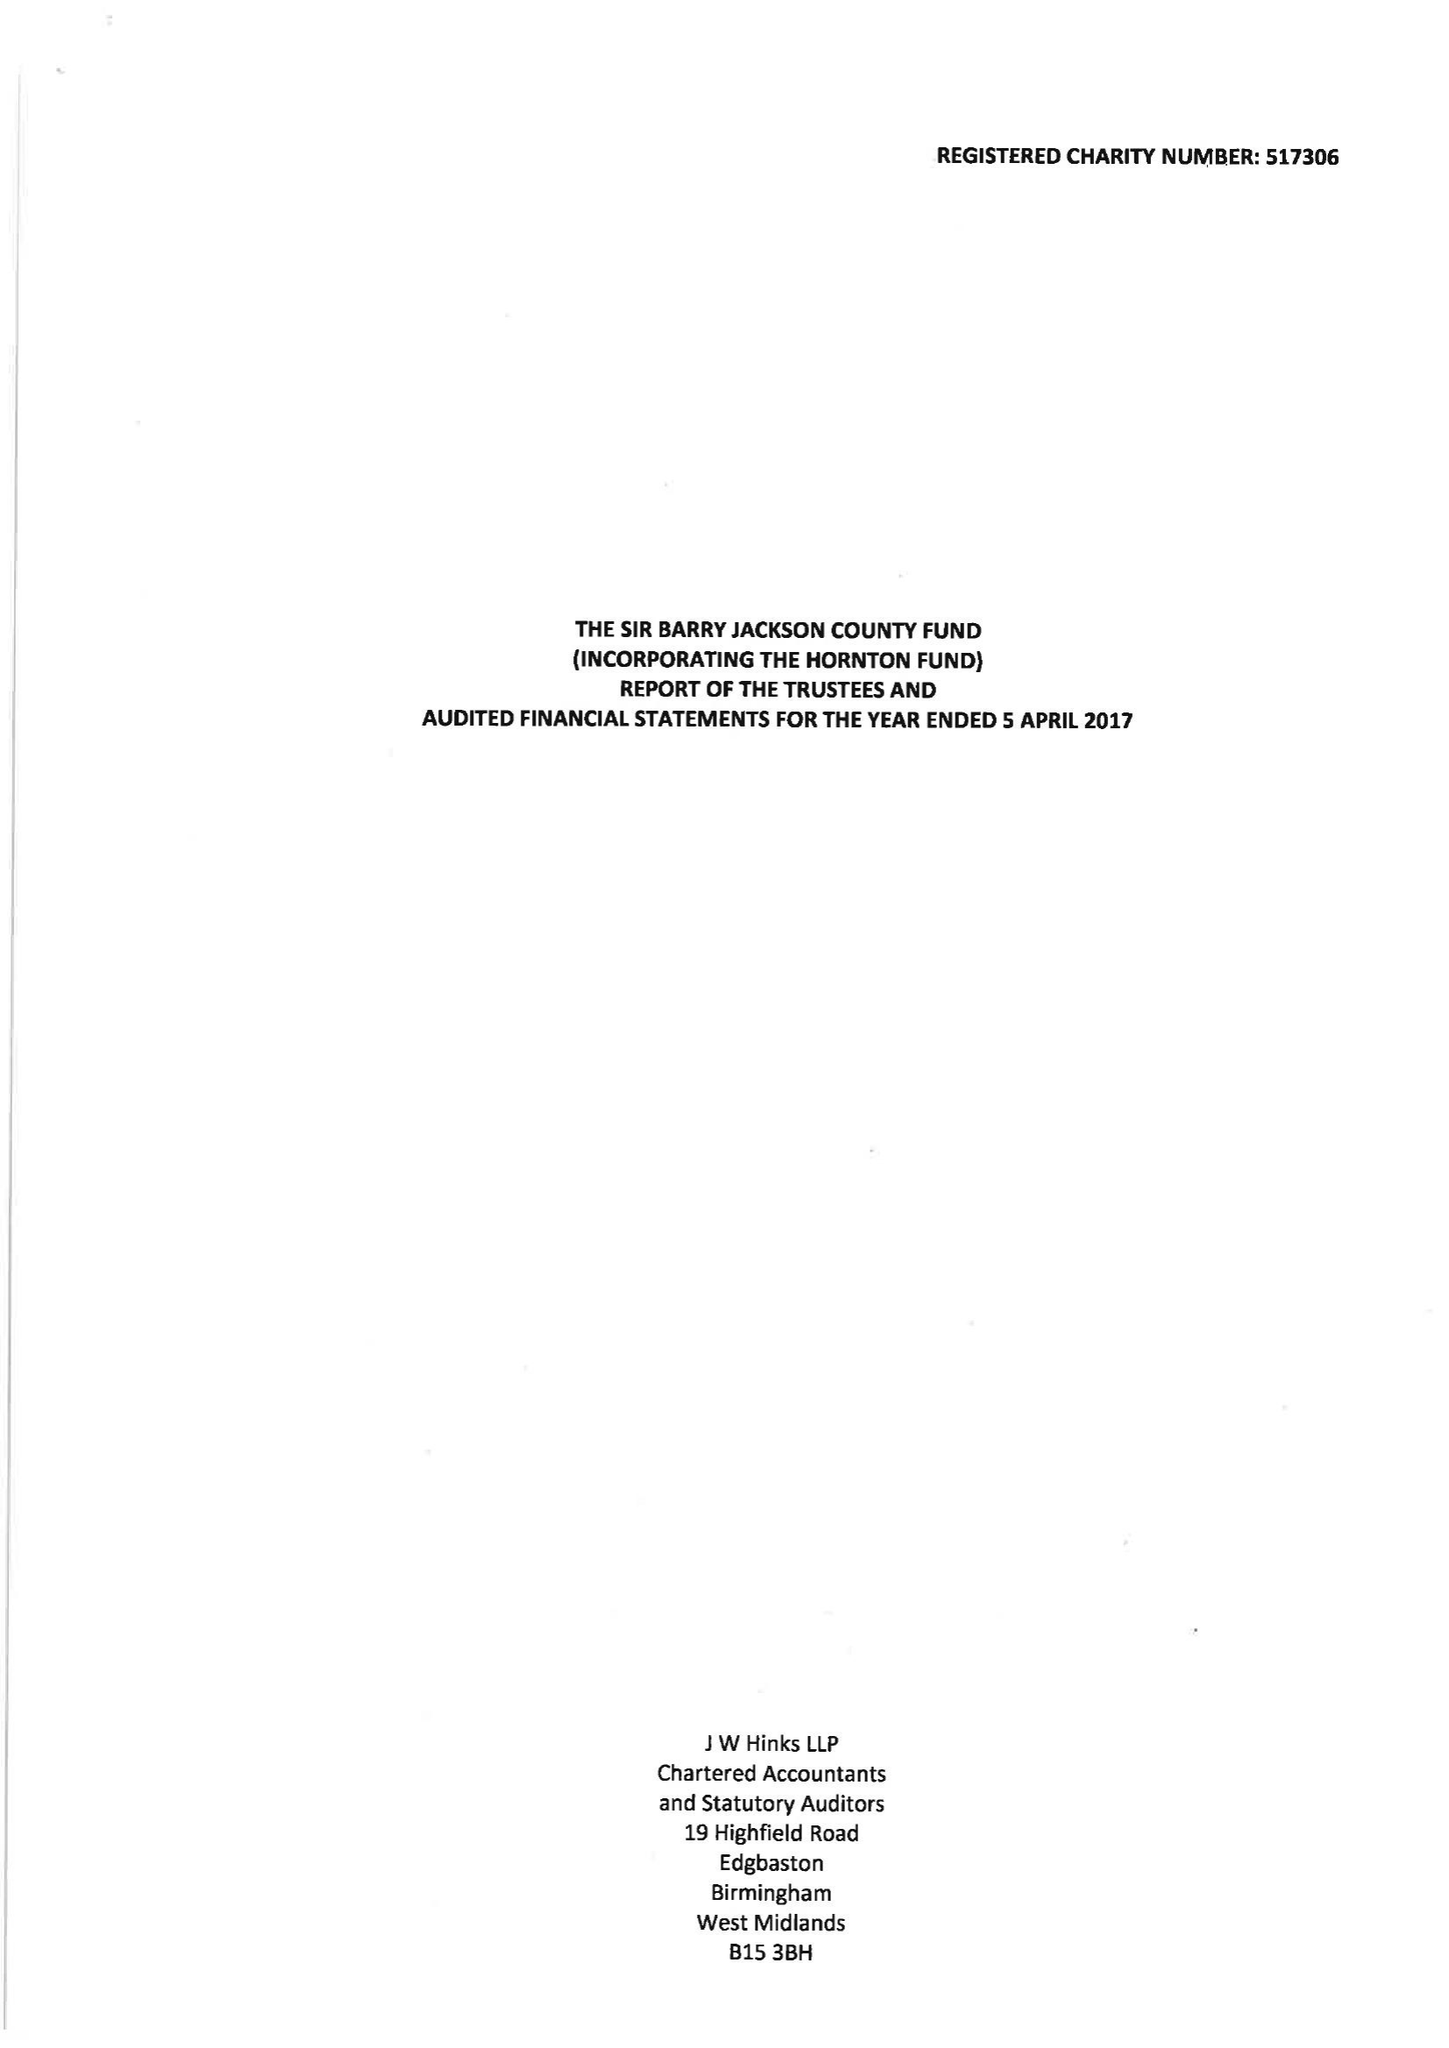What is the value for the charity_number?
Answer the question using a single word or phrase. 517306 